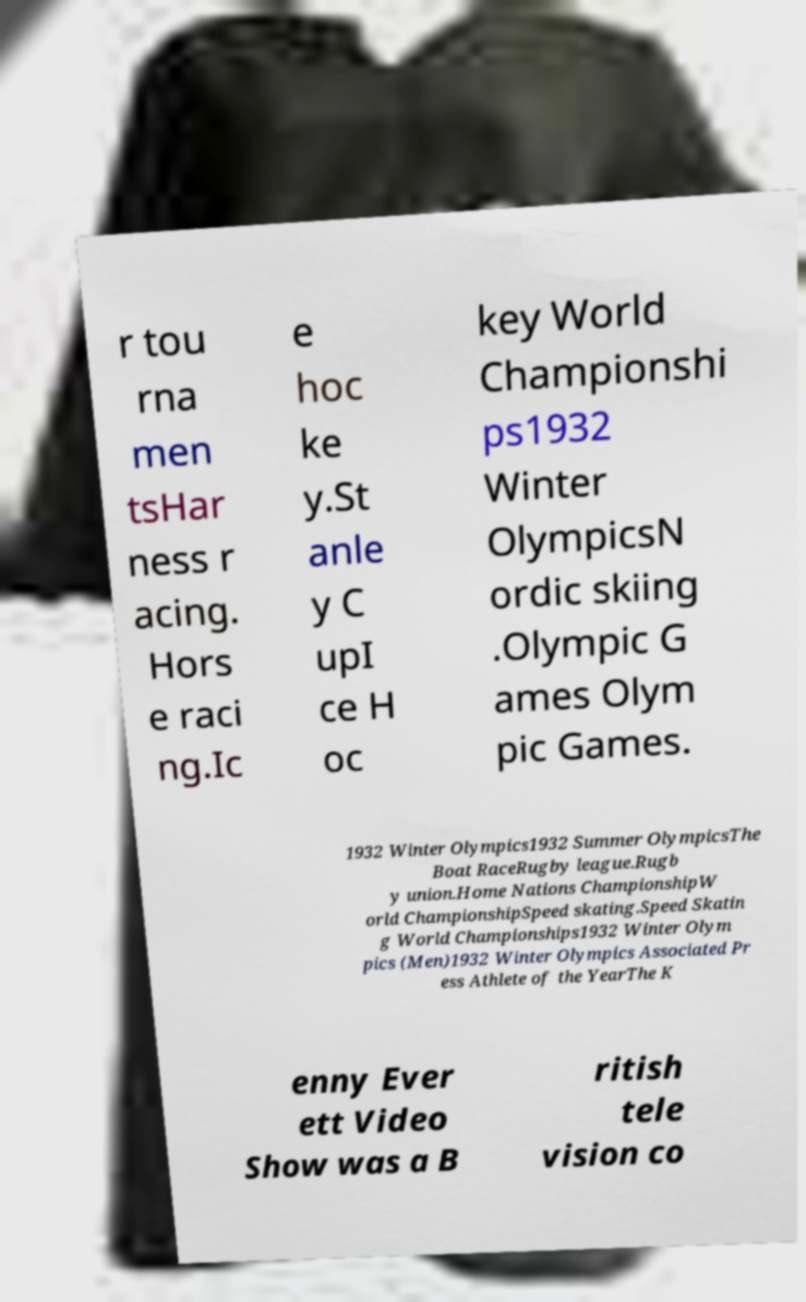Could you extract and type out the text from this image? r tou rna men tsHar ness r acing. Hors e raci ng.Ic e hoc ke y.St anle y C upI ce H oc key World Championshi ps1932 Winter OlympicsN ordic skiing .Olympic G ames Olym pic Games. 1932 Winter Olympics1932 Summer OlympicsThe Boat RaceRugby league.Rugb y union.Home Nations ChampionshipW orld ChampionshipSpeed skating.Speed Skatin g World Championships1932 Winter Olym pics (Men)1932 Winter Olympics Associated Pr ess Athlete of the YearThe K enny Ever ett Video Show was a B ritish tele vision co 